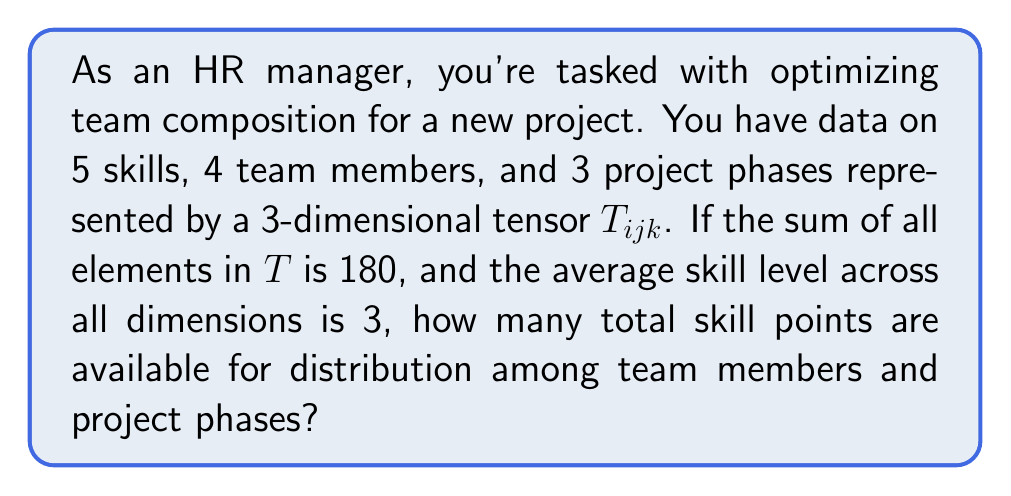Show me your answer to this math problem. Let's approach this step-by-step:

1) First, we need to understand what the tensor $T_{ijk}$ represents:
   - $i$ represents skills (5 skills)
   - $j$ represents team members (4 members)
   - $k$ represents project phases (3 phases)

2) The total number of elements in the tensor is:
   $5 \times 4 \times 3 = 60$

3) We're given that the sum of all elements in $T$ is 180:
   $$\sum_{i=1}^5 \sum_{j=1}^4 \sum_{k=1}^3 T_{ijk} = 180$$

4) We're also told that the average skill level across all dimensions is 3:
   $$\frac{\sum_{i=1}^5 \sum_{j=1}^4 \sum_{k=1}^3 T_{ijk}}{60} = 3$$

5) This confirms our sum, as $60 \times 3 = 180$

6) Now, to find the total skill points available for distribution, we need to multiply the sum by 2:
   $180 \times 2 = 360$

   This is because the average of 3 implies that some skills are above 3 and some are below. By doubling the total, we allow for a full range of skill levels from 0 to 6, with 3 as the average.
Answer: 360 